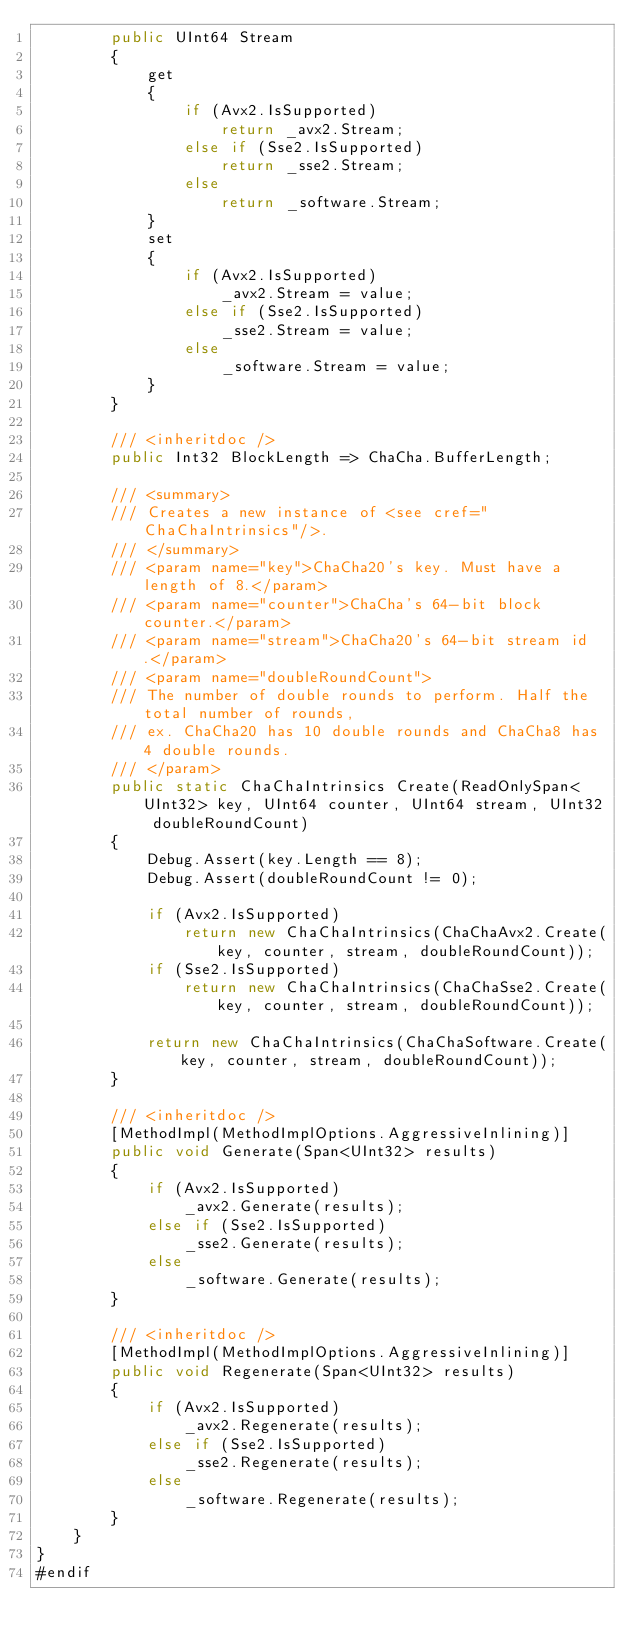Convert code to text. <code><loc_0><loc_0><loc_500><loc_500><_C#_>        public UInt64 Stream
        {
            get
            {
                if (Avx2.IsSupported)
                    return _avx2.Stream;
                else if (Sse2.IsSupported)
                    return _sse2.Stream;
                else
                    return _software.Stream;
            }
            set
            {
                if (Avx2.IsSupported)
                    _avx2.Stream = value;
                else if (Sse2.IsSupported)
                    _sse2.Stream = value;
                else
                    _software.Stream = value;
            }
        }

        /// <inheritdoc />
        public Int32 BlockLength => ChaCha.BufferLength;

        /// <summary>
        /// Creates a new instance of <see cref="ChaChaIntrinsics"/>.
        /// </summary>
        /// <param name="key">ChaCha20's key. Must have a length of 8.</param>
        /// <param name="counter">ChaCha's 64-bit block counter.</param>
        /// <param name="stream">ChaCha20's 64-bit stream id.</param>
        /// <param name="doubleRoundCount">
        /// The number of double rounds to perform. Half the total number of rounds,
        /// ex. ChaCha20 has 10 double rounds and ChaCha8 has 4 double rounds.
        /// </param>
        public static ChaChaIntrinsics Create(ReadOnlySpan<UInt32> key, UInt64 counter, UInt64 stream, UInt32 doubleRoundCount)
        {
            Debug.Assert(key.Length == 8);
            Debug.Assert(doubleRoundCount != 0);

            if (Avx2.IsSupported)
                return new ChaChaIntrinsics(ChaChaAvx2.Create(key, counter, stream, doubleRoundCount));
            if (Sse2.IsSupported)
                return new ChaChaIntrinsics(ChaChaSse2.Create(key, counter, stream, doubleRoundCount));

            return new ChaChaIntrinsics(ChaChaSoftware.Create(key, counter, stream, doubleRoundCount));
        }

        /// <inheritdoc />
        [MethodImpl(MethodImplOptions.AggressiveInlining)]
        public void Generate(Span<UInt32> results)
        {
            if (Avx2.IsSupported)
                _avx2.Generate(results);
            else if (Sse2.IsSupported)
                _sse2.Generate(results);
            else
                _software.Generate(results);
        }

        /// <inheritdoc />
        [MethodImpl(MethodImplOptions.AggressiveInlining)]
        public void Regenerate(Span<UInt32> results)
        {
            if (Avx2.IsSupported)
                _avx2.Regenerate(results);
            else if (Sse2.IsSupported)
                _sse2.Regenerate(results);
            else
                _software.Regenerate(results);
        }
    }
}
#endif
</code> 